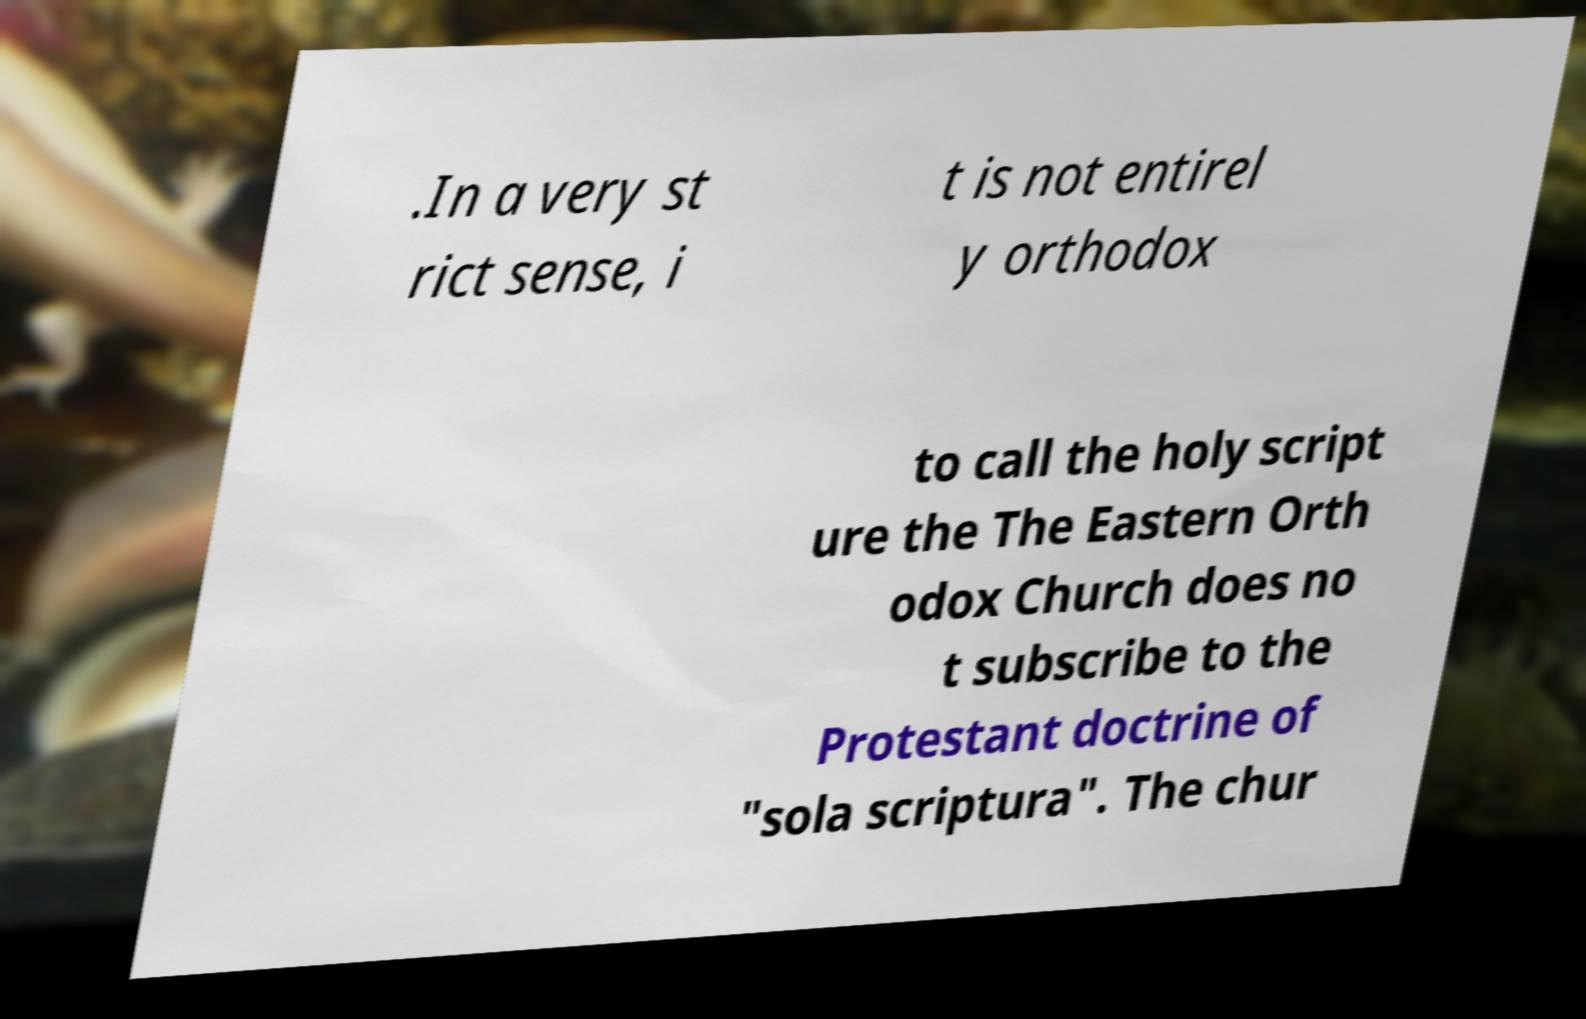What messages or text are displayed in this image? I need them in a readable, typed format. .In a very st rict sense, i t is not entirel y orthodox to call the holy script ure the The Eastern Orth odox Church does no t subscribe to the Protestant doctrine of "sola scriptura". The chur 